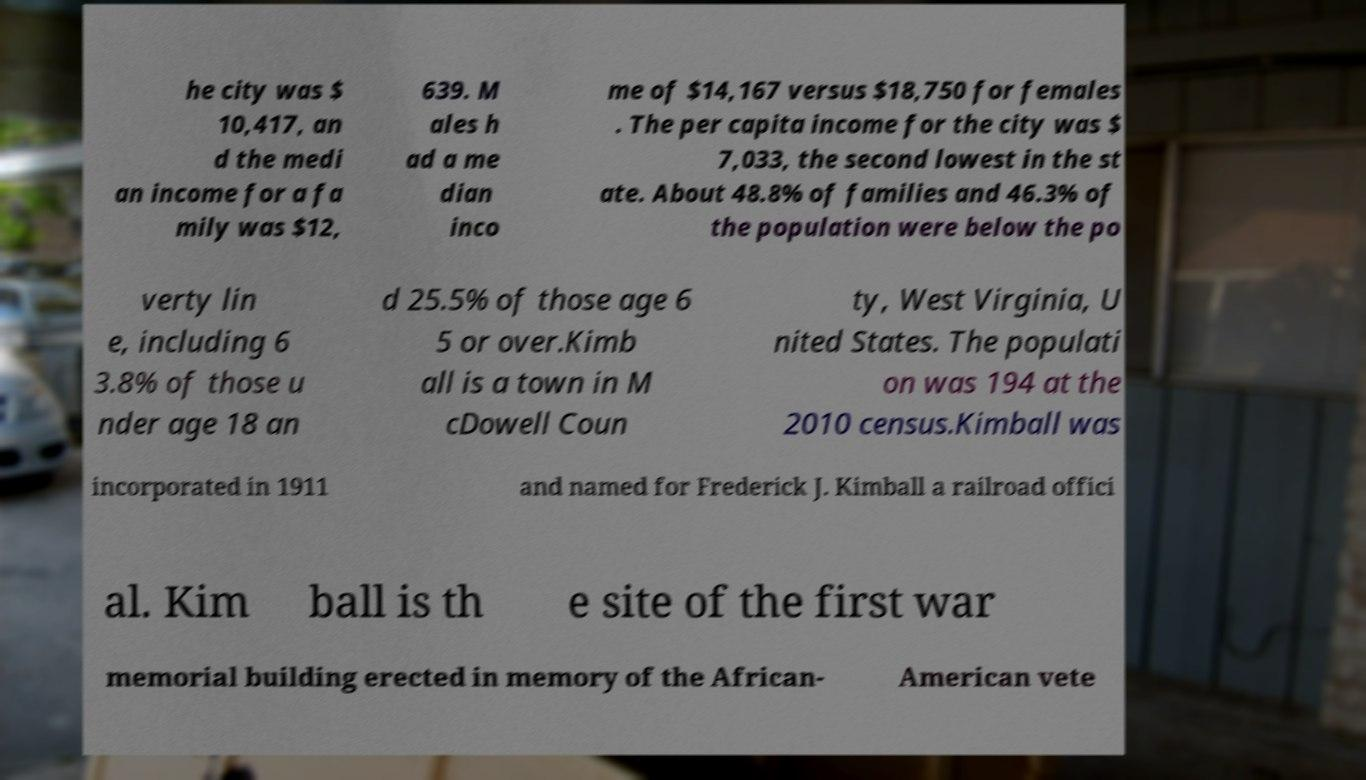What messages or text are displayed in this image? I need them in a readable, typed format. he city was $ 10,417, an d the medi an income for a fa mily was $12, 639. M ales h ad a me dian inco me of $14,167 versus $18,750 for females . The per capita income for the city was $ 7,033, the second lowest in the st ate. About 48.8% of families and 46.3% of the population were below the po verty lin e, including 6 3.8% of those u nder age 18 an d 25.5% of those age 6 5 or over.Kimb all is a town in M cDowell Coun ty, West Virginia, U nited States. The populati on was 194 at the 2010 census.Kimball was incorporated in 1911 and named for Frederick J. Kimball a railroad offici al. Kim ball is th e site of the first war memorial building erected in memory of the African- American vete 